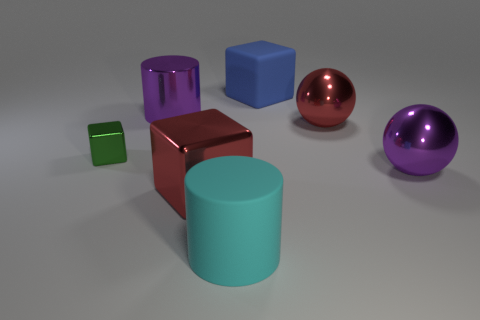How many objects have the same size as the purple ball?
Offer a terse response. 5. There is a red thing that is behind the purple ball in front of the big red ball; what is it made of?
Your response must be concise. Metal. The purple shiny thing behind the shiny block behind the big purple thing on the right side of the blue rubber thing is what shape?
Provide a short and direct response. Cylinder. Is the shape of the big red thing that is in front of the purple ball the same as the blue rubber object behind the small green shiny cube?
Ensure brevity in your answer.  Yes. How many other objects are the same material as the blue thing?
Your answer should be very brief. 1. There is a tiny green object that is made of the same material as the large purple ball; what is its shape?
Provide a short and direct response. Cube. Do the red cube and the cyan rubber cylinder have the same size?
Keep it short and to the point. Yes. There is a purple thing that is to the left of the block right of the red block; what is its size?
Your answer should be compact. Large. The metal object that is the same color as the metal cylinder is what shape?
Provide a short and direct response. Sphere. How many cubes are either blue rubber objects or big cyan things?
Give a very brief answer. 1. 